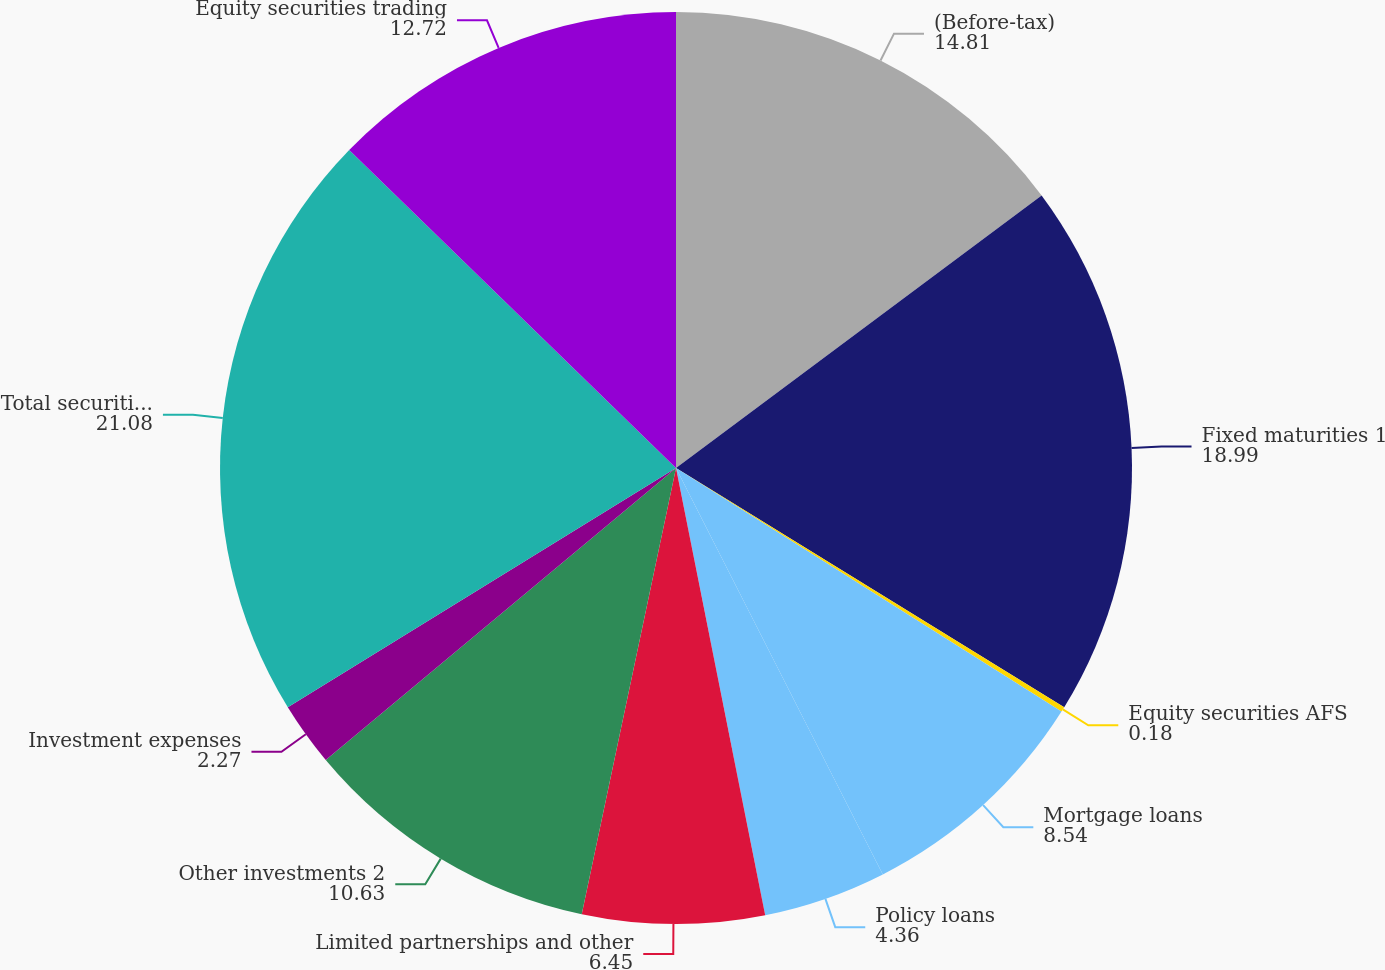Convert chart. <chart><loc_0><loc_0><loc_500><loc_500><pie_chart><fcel>(Before-tax)<fcel>Fixed maturities 1<fcel>Equity securities AFS<fcel>Mortgage loans<fcel>Policy loans<fcel>Limited partnerships and other<fcel>Other investments 2<fcel>Investment expenses<fcel>Total securities AFS and other<fcel>Equity securities trading<nl><fcel>14.81%<fcel>18.99%<fcel>0.18%<fcel>8.54%<fcel>4.36%<fcel>6.45%<fcel>10.63%<fcel>2.27%<fcel>21.08%<fcel>12.72%<nl></chart> 